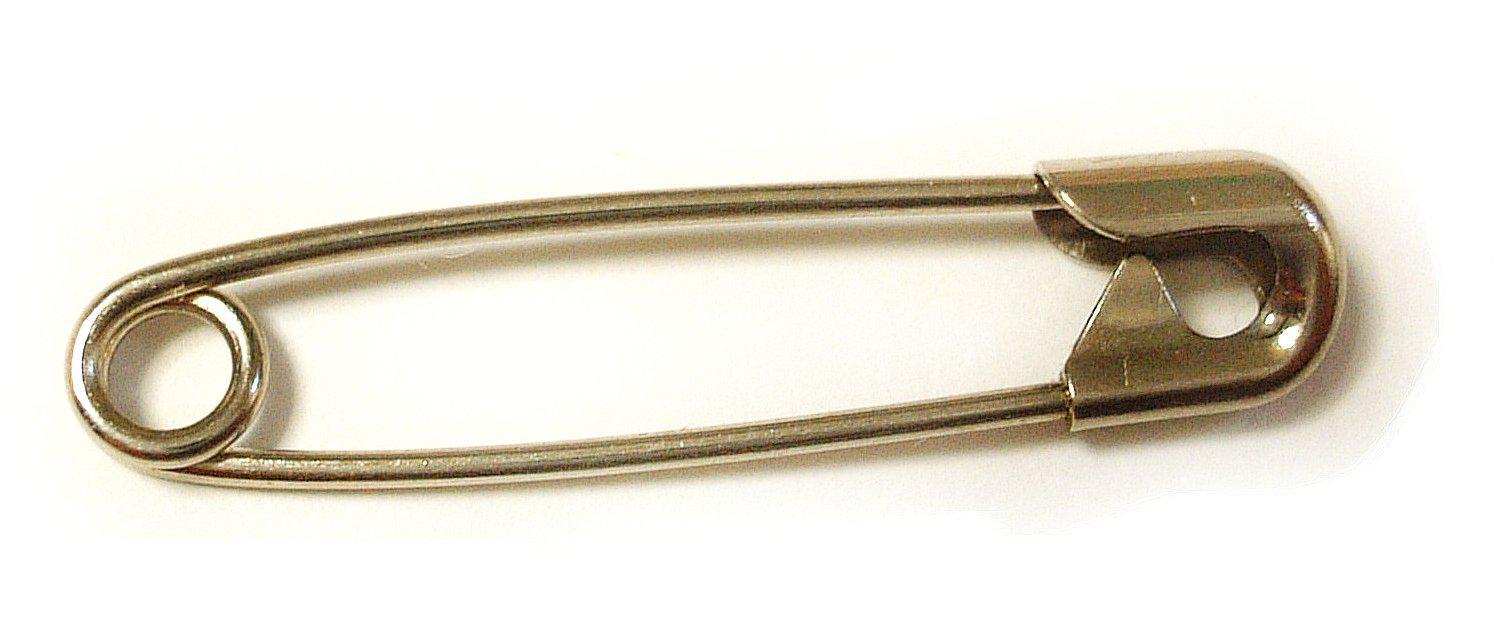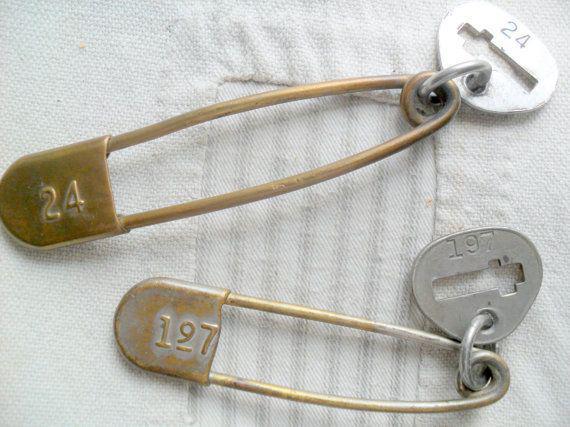The first image is the image on the left, the second image is the image on the right. For the images displayed, is the sentence "The right image contains exactly two safety pins." factually correct? Answer yes or no. Yes. The first image is the image on the left, the second image is the image on the right. Examine the images to the left and right. Is the description "One image contains a single, open safety pin, and the other image shows two closed pins of a different style." accurate? Answer yes or no. No. 